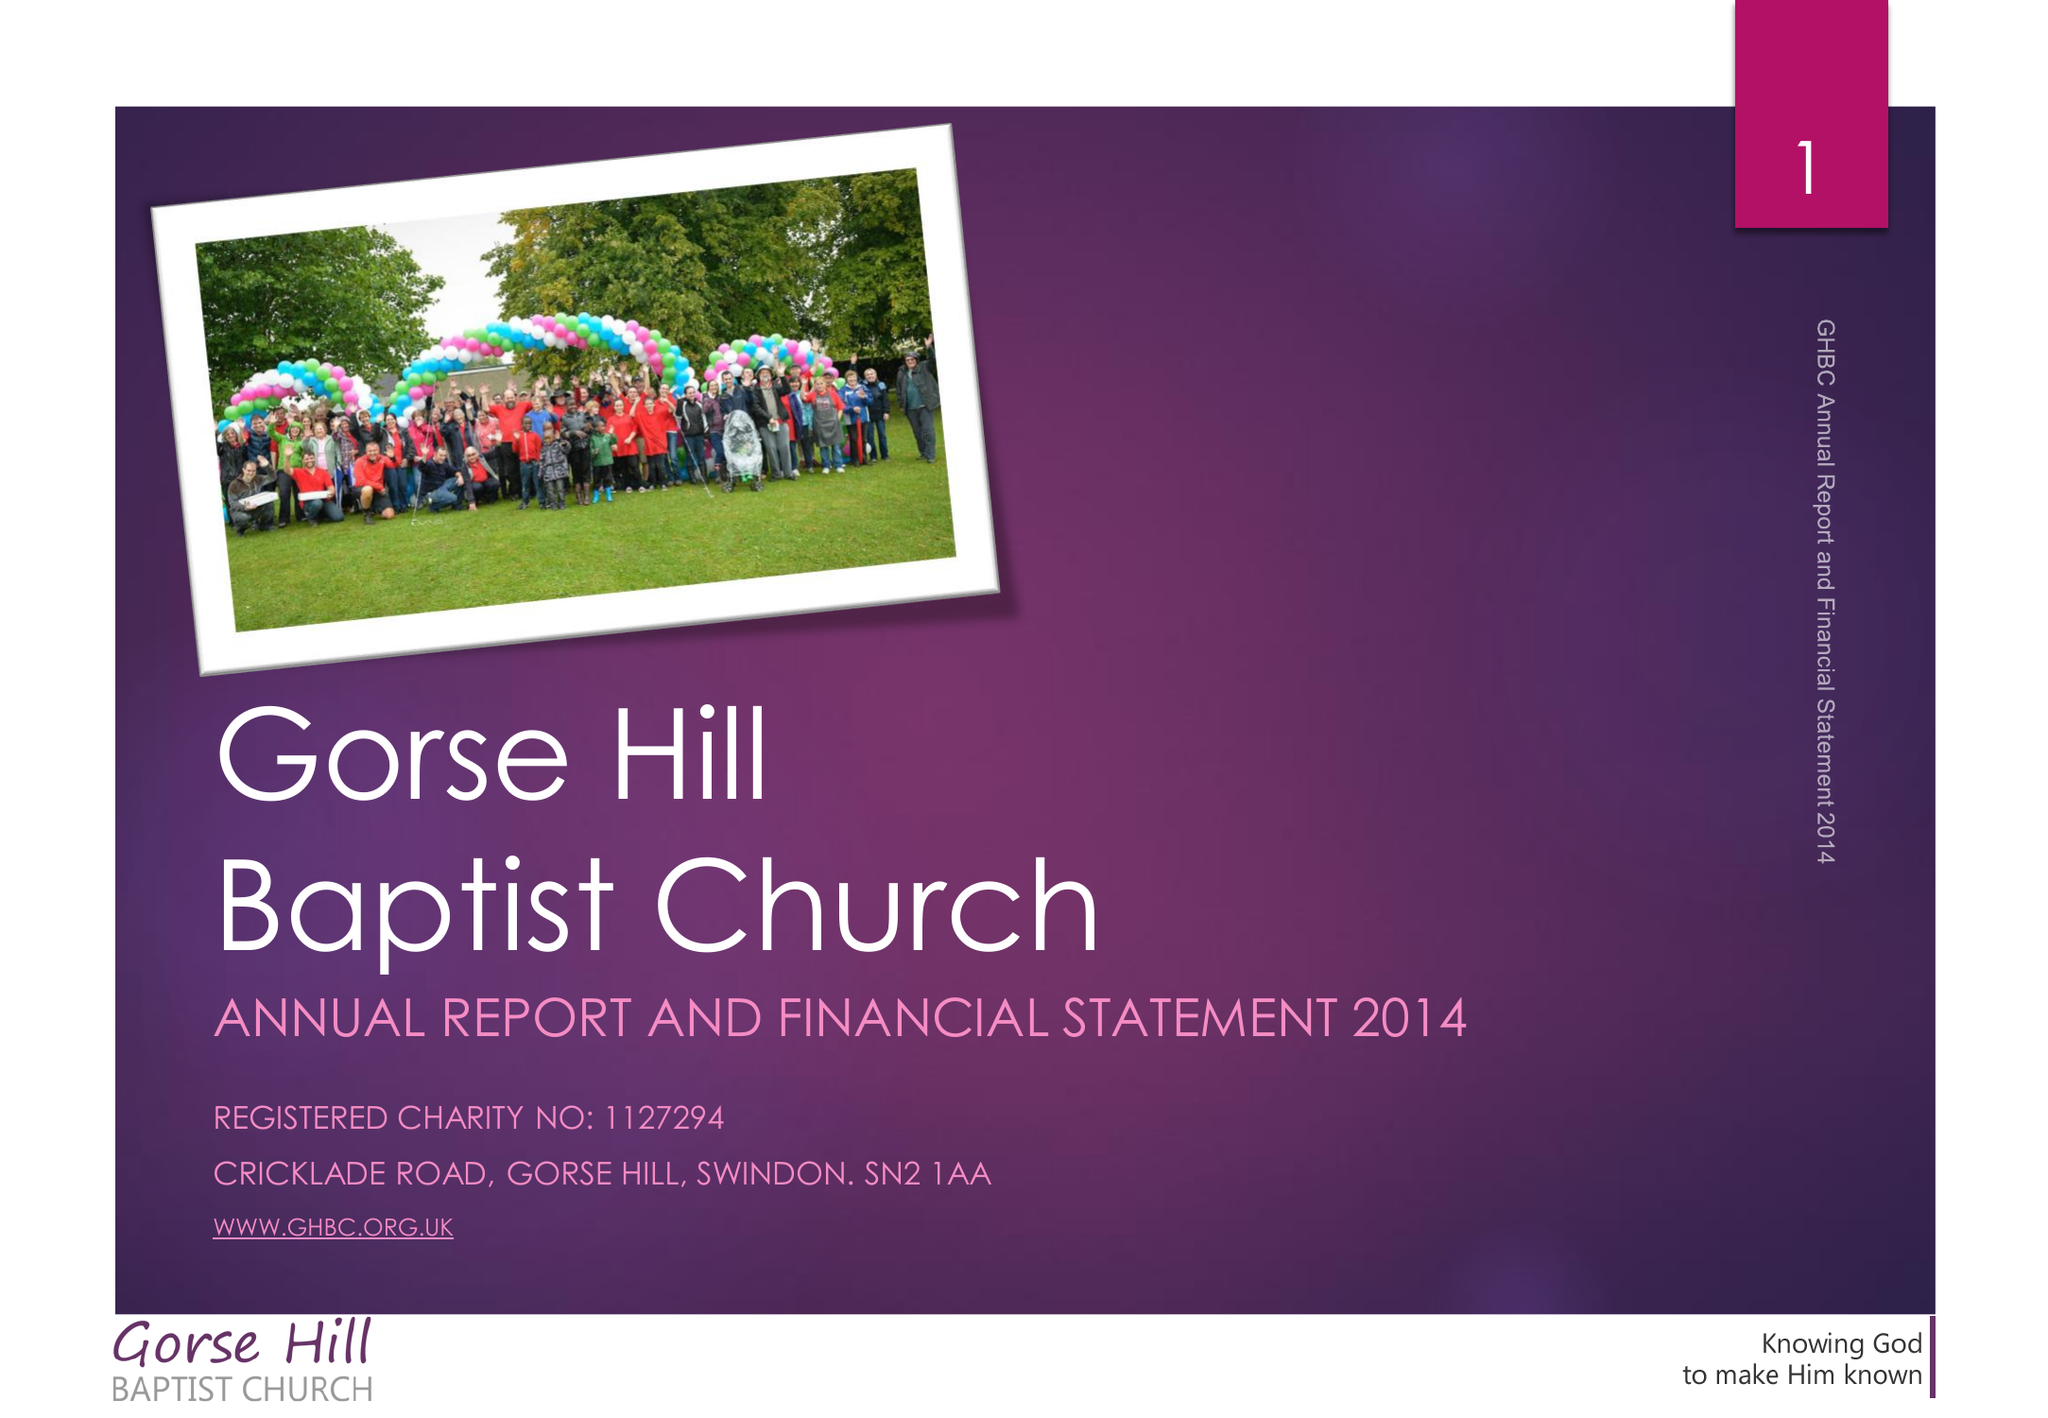What is the value for the report_date?
Answer the question using a single word or phrase. 2014-12-31 